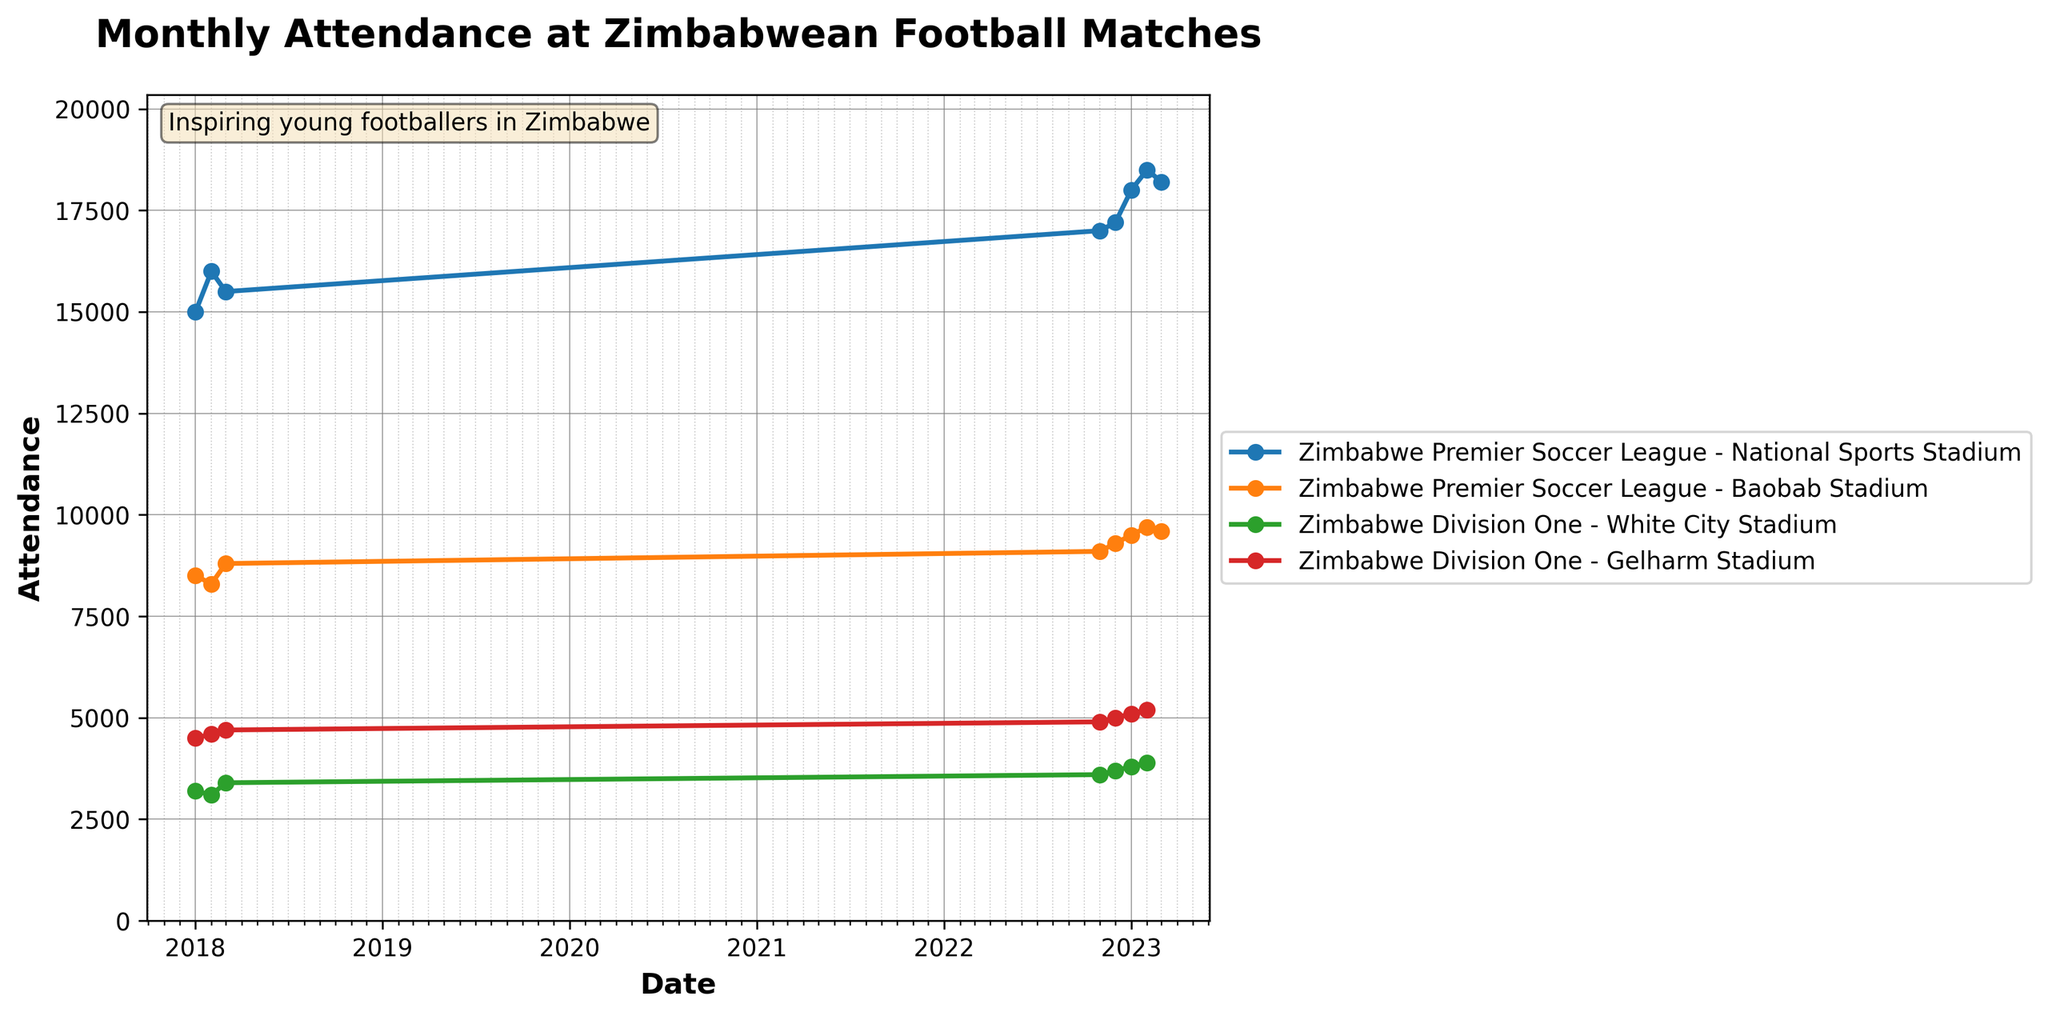What is the title of the figure? The title is usually placed at the top of the figure to indicate the main subject of the plot. In this case, it is about monthly attendance at Zimbabwean football matches.
Answer: Monthly Attendance at Zimbabwean Football Matches How does the attendance at the National Sports Stadium change from January 2023 to February 2023? Identify the attendance values for the National Sports Stadium in January 2023 and February 2023, then determine the change by subtraction.
Answer: It increases by 500 (18000 to 18500) What is the general trend of attendance at Baobab Stadium over the last five months shown in the plot? Analyze the attendance values at Baobab Stadium from November 2022 to March 2023, noticing the general direction of the values.
Answer: Generally increasing Which stadium has the highest attendance in March 2023, and what is the value? Look at the attendance values of all stadiums for March 2023 and identify the highest one.
Answer: National Sports Stadium, 18200 How does the attendance at White City Stadium in March 2023 compare to January 2018? Look up the attendance values of White City Stadium in both March 2023 and January 2018 and compare them.
Answer: It is higher in March 2023 (3900 compared to 3200) Comparing the Zimbabwe Premier Soccer League to Zimbabwe Division One, which league shows more attendance variation across the different stadiums in March 2023? Compare the attendance at National Sports Stadium and Baobab Stadium for the Premier League to the attendance at White City Stadium and Gelharm Stadium for Division One in March 2023. Evaluate which one has a greater difference between the highest and lowest values.
Answer: Zimbabwe Premier Soccer League increases by 8600 (18200 - 9600) What can be inferred about the overall attendance trend at the National Sports Stadium from January 2018 to March 2023? Identify the attendance values over time from January 2018 to March 2023 for the National Sports Stadium. Determine if the values generally increase, decrease, or stay constant.
Answer: Generally increasing 